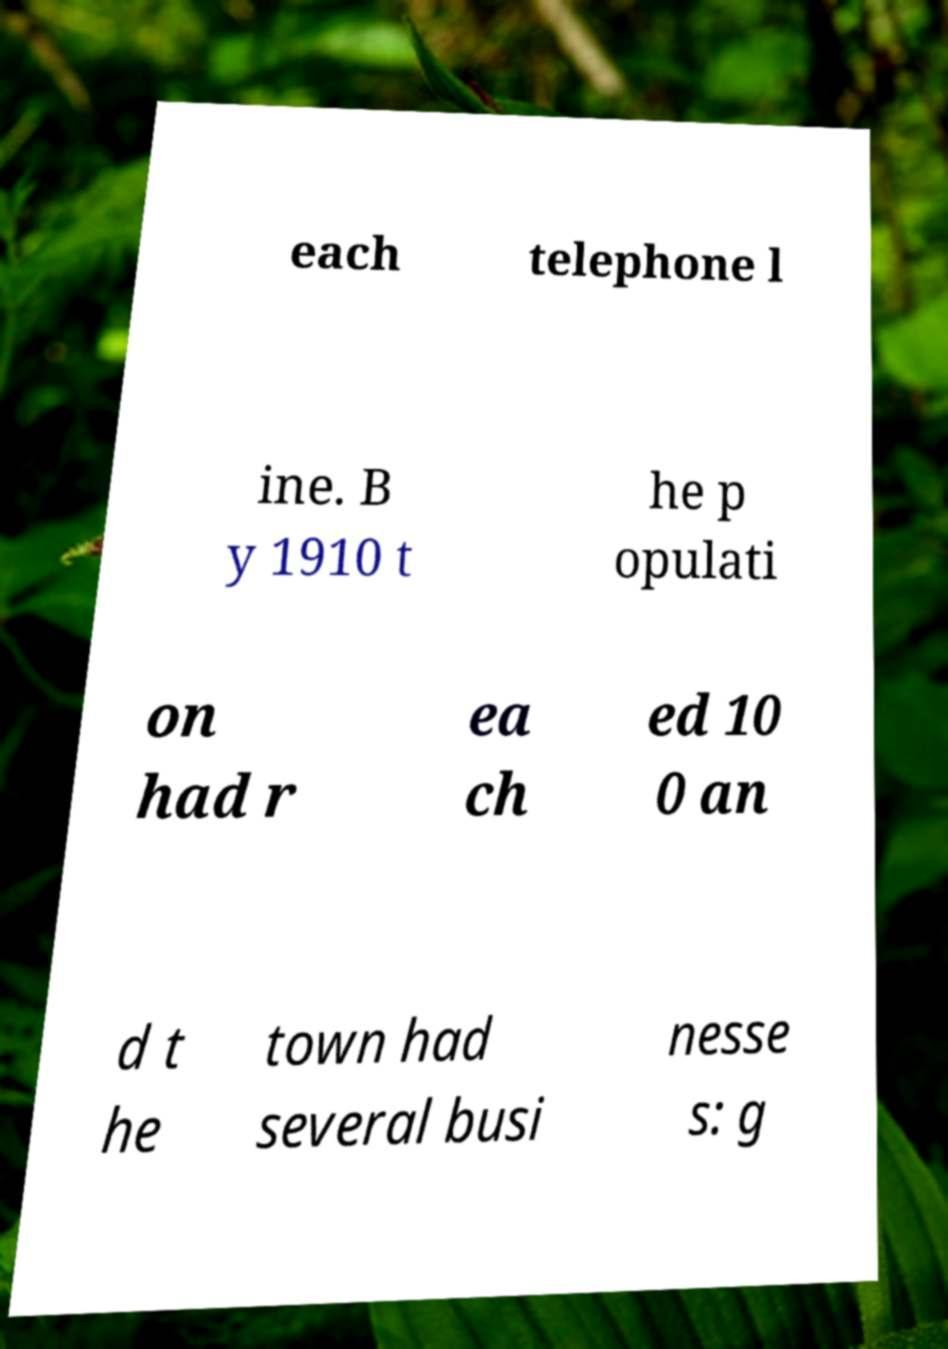Please read and relay the text visible in this image. What does it say? each telephone l ine. B y 1910 t he p opulati on had r ea ch ed 10 0 an d t he town had several busi nesse s: g 